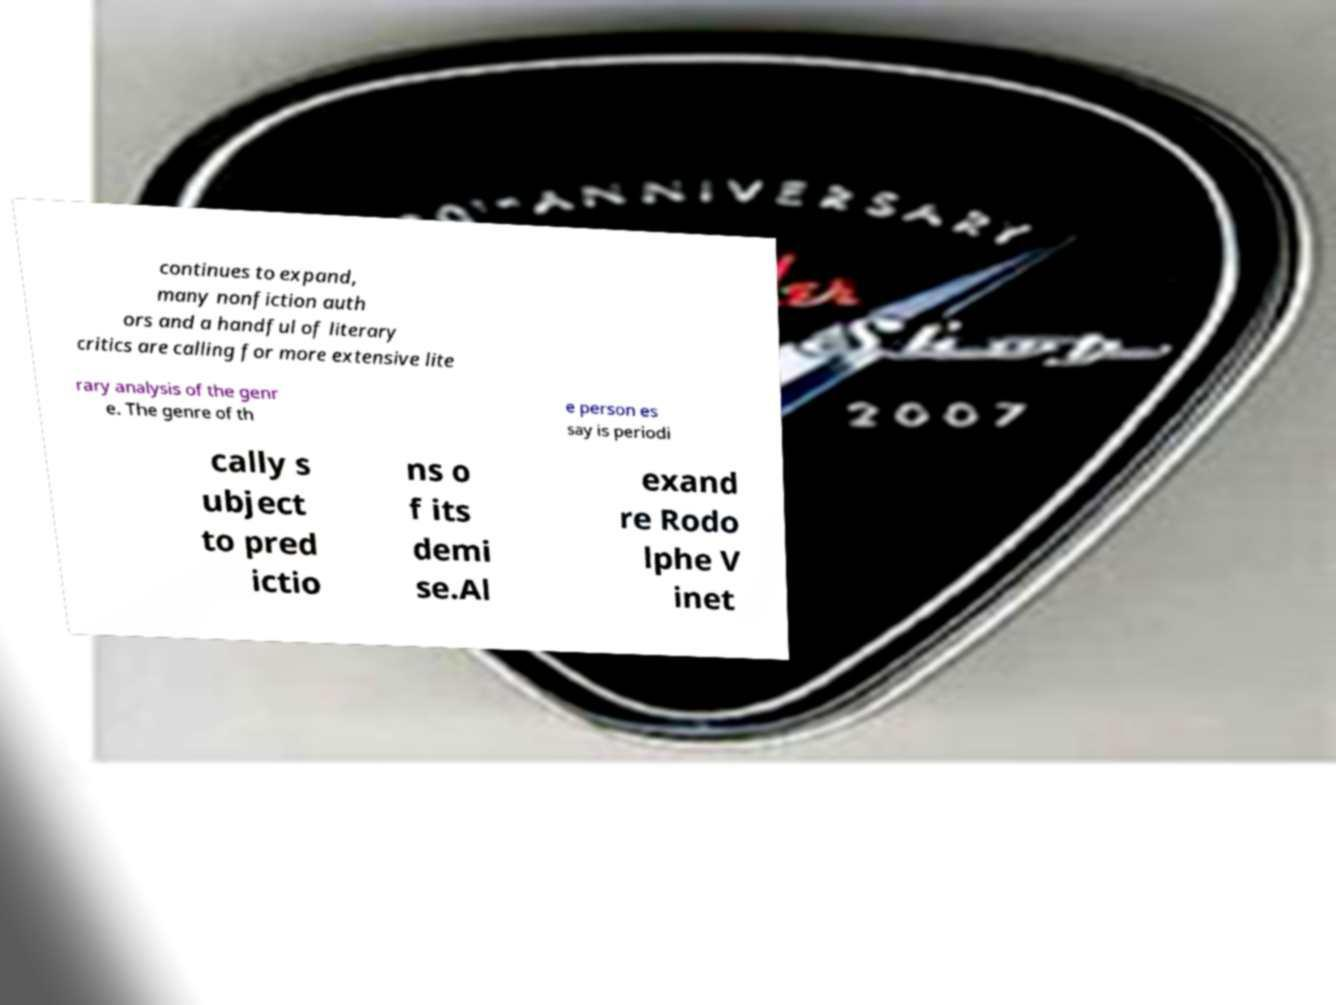For documentation purposes, I need the text within this image transcribed. Could you provide that? continues to expand, many nonfiction auth ors and a handful of literary critics are calling for more extensive lite rary analysis of the genr e. The genre of th e person es say is periodi cally s ubject to pred ictio ns o f its demi se.Al exand re Rodo lphe V inet 